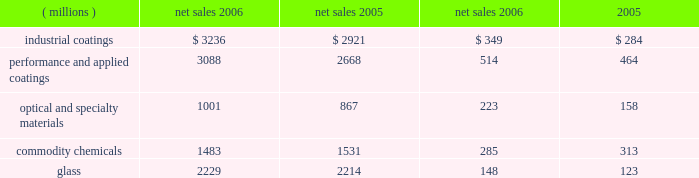Management 2019s discussion and analysis value of the company 2019s obligation relating to asbestos claims under the ppg settlement arrangement .
The legal settlements net of insurance included aftertax charges of $ 80 million for the marvin legal settlement , net of insurance recoveries of $ 11 million , and $ 37 million for the impact of the federal glass class action antitrust legal settlement .
Results of reportable business segments net sales segment income ( millions ) 2006 2005 2006 2005 .
Industrial coatings sales increased $ 315 million or 11% ( 11 % ) in 2006 .
Sales increased 4% ( 4 % ) due to acquisitions , 4% ( 4 % ) due to increased volumes in the automotive , industrial and packaging coatings operating segments , 2% ( 2 % ) due to higher selling prices , particularly in the industrial and packaging coatings businesses and 1% ( 1 % ) due to the positive effects of foreign currency translation .
Segment income increased $ 65 million in 2006 .
The increase in segment income was primarily due to the impact of increased sales volume , lower overhead and manufacturing costs , and the impact of acquisitions .
Segment income was reduced by the adverse impact of inflation , which was substantially offset by higher selling prices .
Performance and applied coatings sales increased $ 420 million or 16% ( 16 % ) in 2006 .
Sales increased 8% ( 8 % ) due to acquisitions , 4% ( 4 % ) due to higher selling prices in the refinish , aerospace and architectural coatings operating segments , 3% ( 3 % ) due to increased volumes in our aerospace and architectural coatings businesses and 1% ( 1 % ) due to the positive effects of foreign currency translation .
Segment income increased $ 50 million in 2006 .
The increase in segment income was primarily due to the impact of increased sales volume and higher selling prices , which more than offset the impact of inflation .
Segment income was reduced by increased overhead costs to support growth in our architectural coatings business .
Optical and specialty materials sales increased $ 134 million or 15% ( 15 % ) in 2006 .
Sales increased 10% ( 10 % ) due to higher volumes , particularly in optical products and fine chemicals and 5% ( 5 % ) due to acquisitions in our optical products business .
Segment income increased $ 65 million in 2006 .
The absence of the 2005 charge for an asset impairment in our fine chemicals business increased segment income by $ 27 million .
The remaining $ 38 million increase in segment income was primarily due to increased volumes , lower manufacturing costs , and the absence of the 2005 hurricane costs of $ 3 million , net of 2006 insurance recoveries , which were only partially offset by increased overhead costs in our optical products business to support growth and the negative impact of inflation .
Commodity chemicals sales decreased $ 48 million or 3% ( 3 % ) in 2006 .
Sales decreased 4% ( 4 % ) due to lower chlor-alkali volumes and increased 1% ( 1 % ) due to higher selling prices .
Segment income decreased $ 28 million in 2006 .
The year- over-year decline in segment income was due primarily to lower sales volumes and higher manufacturing costs associated with reduced production levels .
The absence of the 2005 charges for direct costs related to hurricanes increased segment income by $ 29 million .
The impact of higher selling prices ; lower inflation , primarily natural gas costs , and an insurance recovery of $ 10 million related to the 2005 hurricane losses also increased segment income in 2006 .
Our fourth-quarter chlor-alkali sales volumes and earnings were negatively impacted by production outages at several customers over the last two months of 2006 .
It is uncertain when some of these customers will return to a normal level of production which may impact the sales and earnings of our chlor-alkali business in early 2007 .
Glass sales increased $ 15 million or 1% ( 1 % ) in 2006 .
Sales increased 1% ( 1 % ) due to improved volumes resulting from a combination of organic growth and an acquisition .
A slight positive impact on sales due to foreign currency translation offset a slight decline in pricing .
Volumes increased in the performance glazings , automotive replacement glass and services and fiber glass businesses .
Automotive oem glass volume declined during 2006 .
Pricing was also up in performance glazings , but declined in the other glass businesses .
Segment income increased $ 25 million in 2006 .
This increase in segment income was primarily the result of higher equity earnings from our asian fiber glass joint ventures , higher royalty income and lower manufacturing and natural gas costs , which more than offset the negative impacts of higher inflation , lower margin mix of sales and reduced selling prices .
Our fiber glass operating segment made progress during 2006 in achieving our multi-year plan to improve profitability and cash flow .
A transformation of our supply chain , which includes production of a more focused product mix at each manufacturing plant , manufacturing cost reduction initiatives and improved equity earnings from our asian joint ventures are the primary focus and represent the critical success factors in this plan .
During 2006 , our new joint venture in china started producing high labor content fiber glass reinforcement products , which will allow us to refocus our u.s .
Production capacity on higher margin , direct process products .
The 2006 earnings improvement by our fiber glass operating segment accounted for the bulk of the 2006 improvement in the glass reportable business segment income .
20 2006 ppg annual report and form 10-k 4282_txt .
What was the volume impact on sales in the industrial coatings segment ( millions ) ? 
Computations: (2921 * 4%)
Answer: 116.84. 